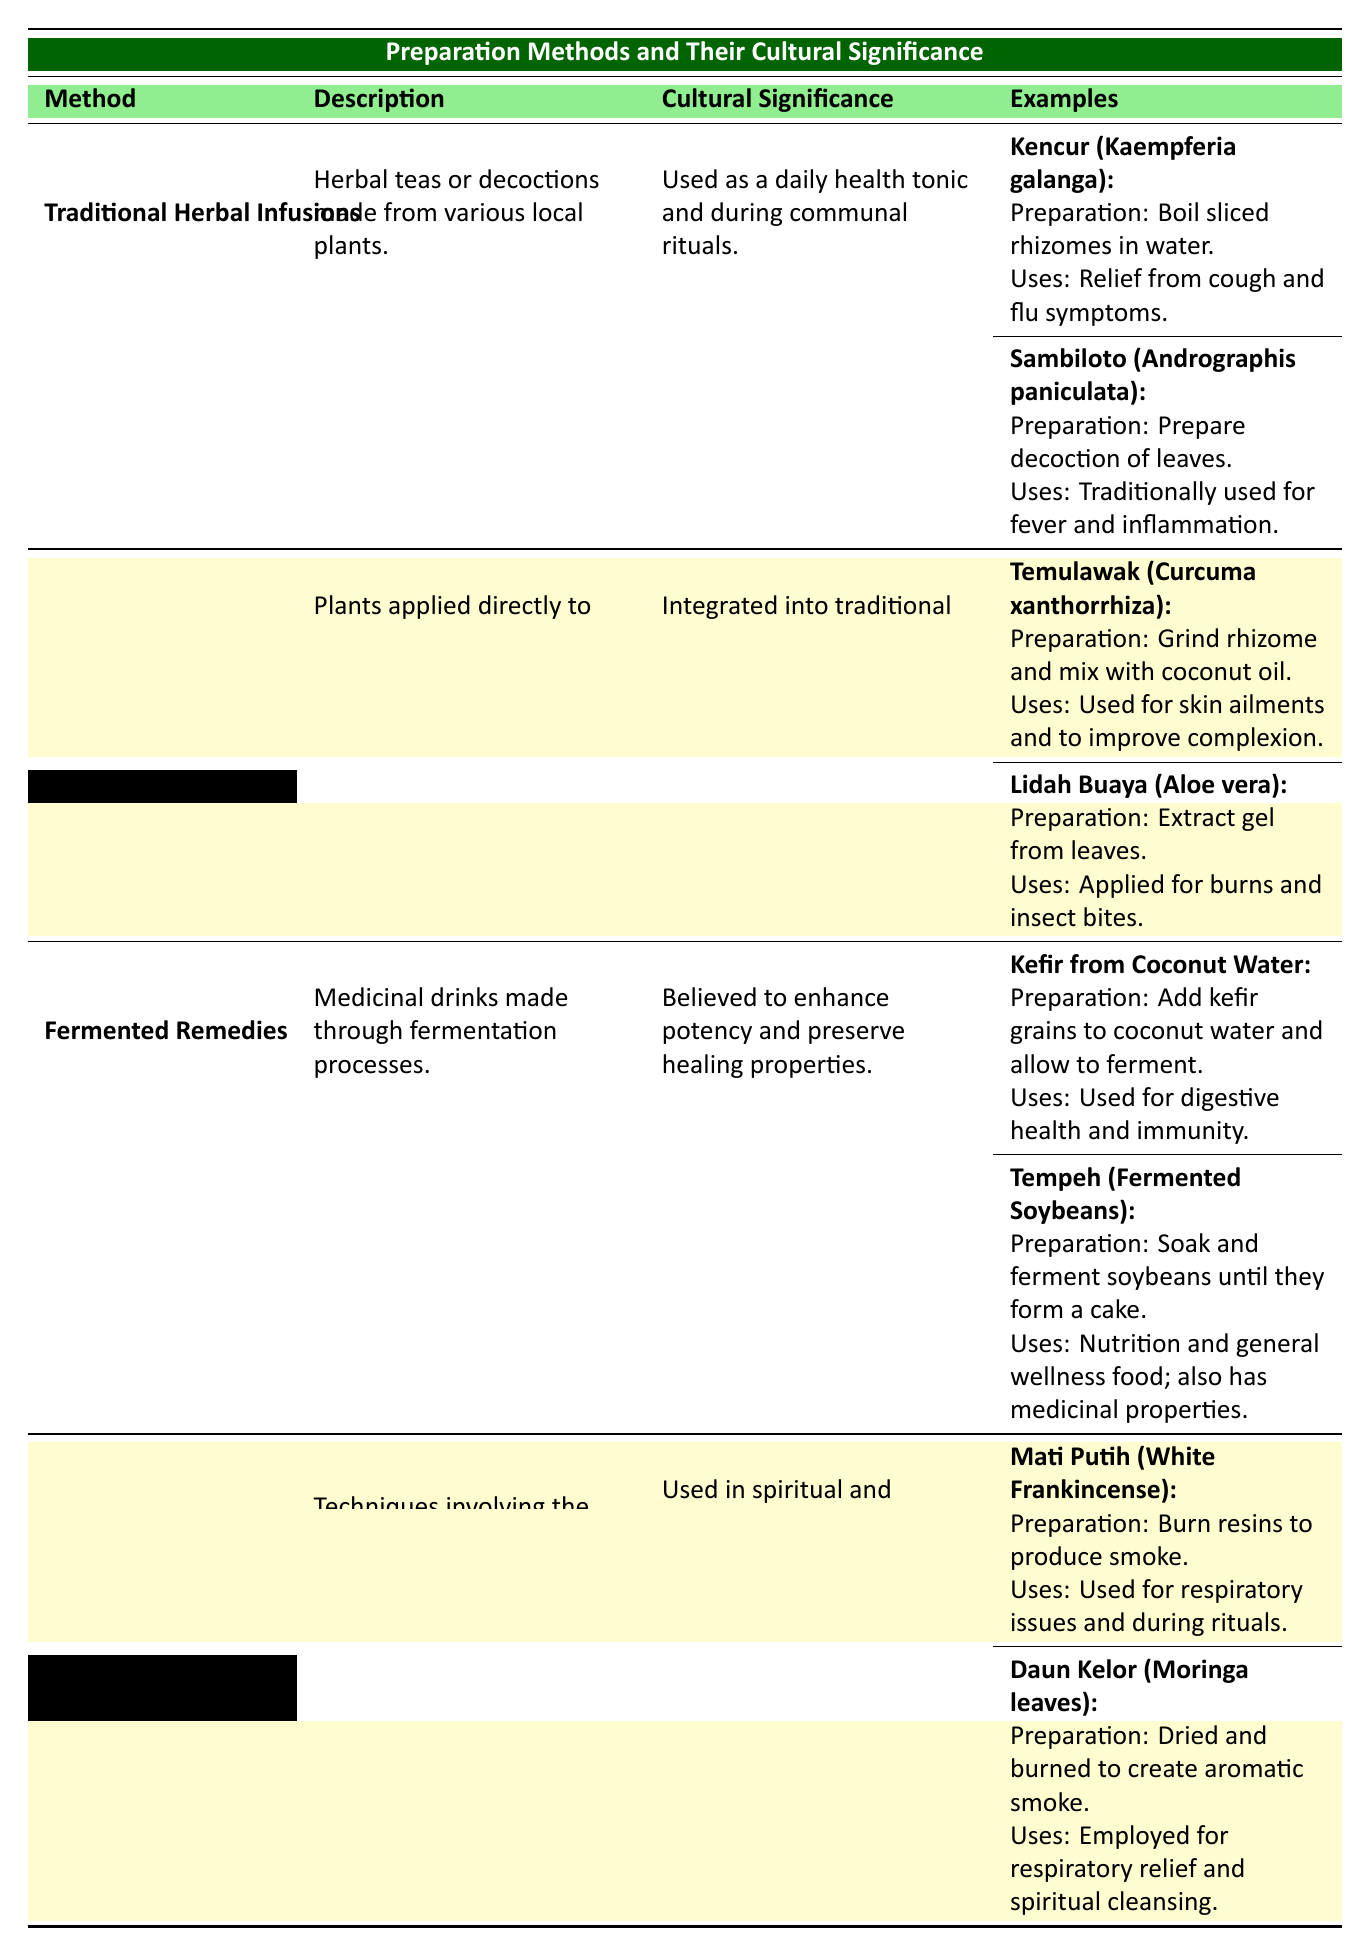What is the cultural significance of Traditional Herbal Infusions? According to the table, Traditional Herbal Infusions are used as a daily health tonic and during communal rituals, highlighting their importance in everyday and social contexts.
Answer: Used as a daily health tonic and during communal rituals How do you prepare Sambiloto? The table specifies that Sambiloto is prepared by making a decoction of its leaves.
Answer: Prepare decoction of leaves What is the use of Temulawak? From the table, it can be seen that Temulawak is used for skin ailments and to improve complexion, thus serving both cosmetic and therapeutic purposes.
Answer: Used for skin ailments and to improve complexion What method involves techniques for inhaling herbal smoke? The table indicates that Smoke and Inhalation Therapies involve techniques for inhaling herbal smoke, specifically used for spiritual purification.
Answer: Smoke and Inhalation Therapies Are topical applications used for internal conditions? The table does not mention that topical applications are used for internal conditions; they are specifically applied to the skin for therapeutic effects.
Answer: No What preparation is associated with Kefir from Coconut Water? The preparation method for Kefir from Coconut Water involves adding kefir grains to coconut water and allowing it to ferment, a process designed to enhance its properties.
Answer: Add kefir grains to coconut water and allow to ferment Which preparation method is believed to enhance potency through fermentation? The table states that Fermented Remedies, which include drinks like Kefir and Tempeh, are believed to enhance potency and preserve healing properties.
Answer: Fermented Remedies How many medicinal examples are provided under Traditional Herbal Infusions? There are two medicinal examples listed under Traditional Herbal Infusions: Kencur and Sambiloto, which can be counted from the data in the table.
Answer: 2 What is the common feature of Traditional Herbal Infusions and Fermented Remedies? Both Traditional Herbal Infusions and Fermented Remedies are forms of preparations derived from local plants, serving both health benefits and cultural significance, though they utilize different methods.
Answer: Derived from local plants with health benefits 